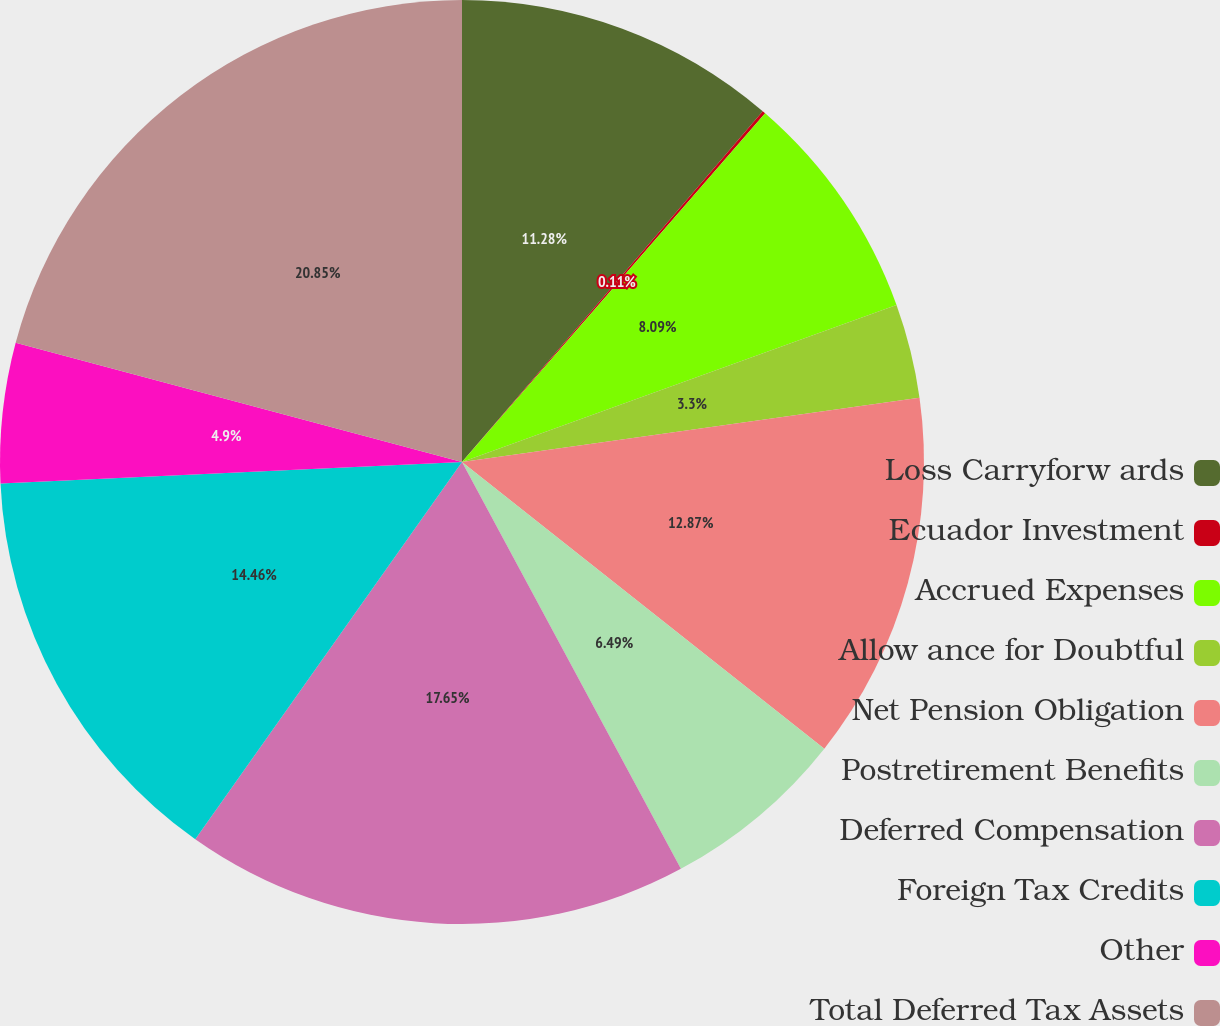Convert chart. <chart><loc_0><loc_0><loc_500><loc_500><pie_chart><fcel>Loss Carryforw ards<fcel>Ecuador Investment<fcel>Accrued Expenses<fcel>Allow ance for Doubtful<fcel>Net Pension Obligation<fcel>Postretirement Benefits<fcel>Deferred Compensation<fcel>Foreign Tax Credits<fcel>Other<fcel>Total Deferred Tax Assets<nl><fcel>11.28%<fcel>0.11%<fcel>8.09%<fcel>3.3%<fcel>12.87%<fcel>6.49%<fcel>17.65%<fcel>14.46%<fcel>4.9%<fcel>20.84%<nl></chart> 